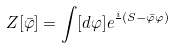<formula> <loc_0><loc_0><loc_500><loc_500>Z [ \bar { \varphi } ] = \int [ d \varphi ] e ^ { \frac { i } { } ( S - \bar { \varphi } \varphi ) }</formula> 